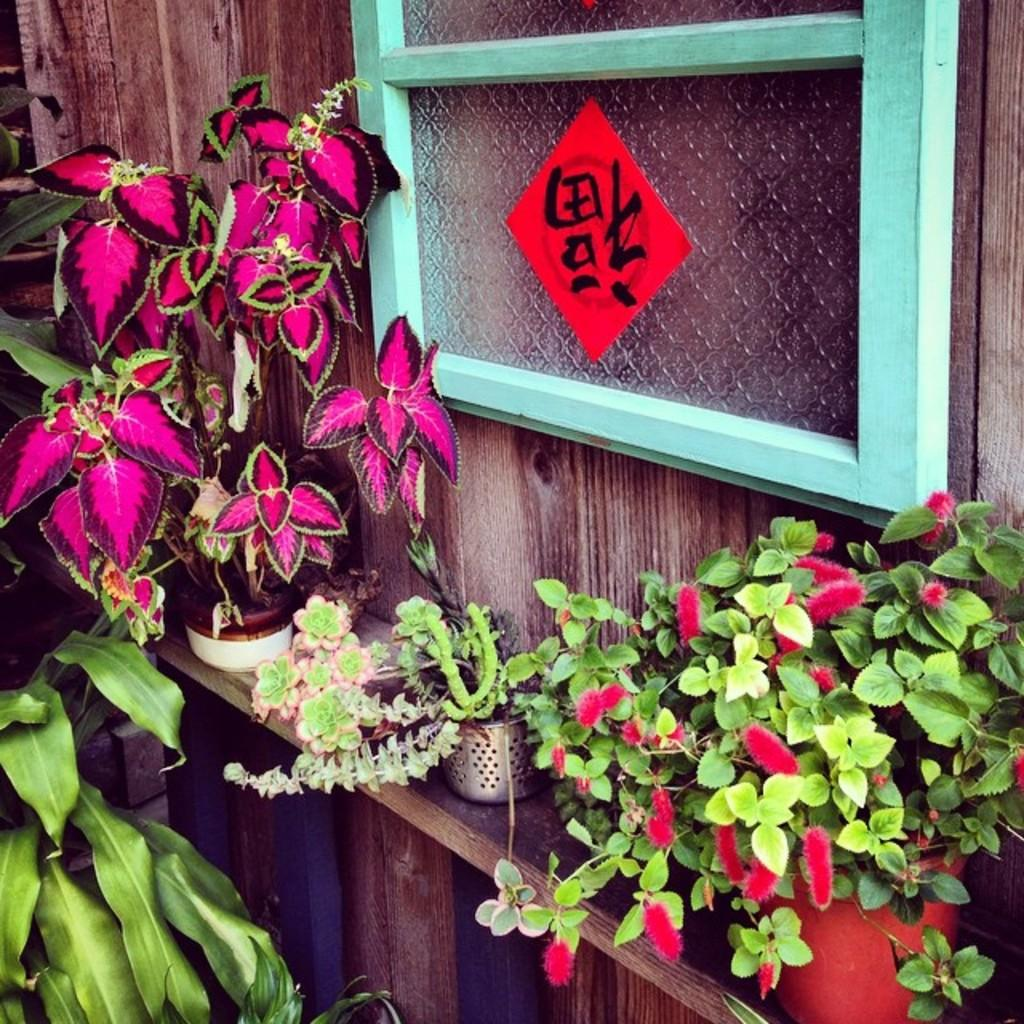What type of objects can be seen in the image? There are plant pots in the image. What material is the wall in the image made of? The wall in the image is made of wood. What architectural feature is present in the image? There is a window in the image. What type of feast is being prepared in the image? There is no feast or any indication of food preparation in the image. 